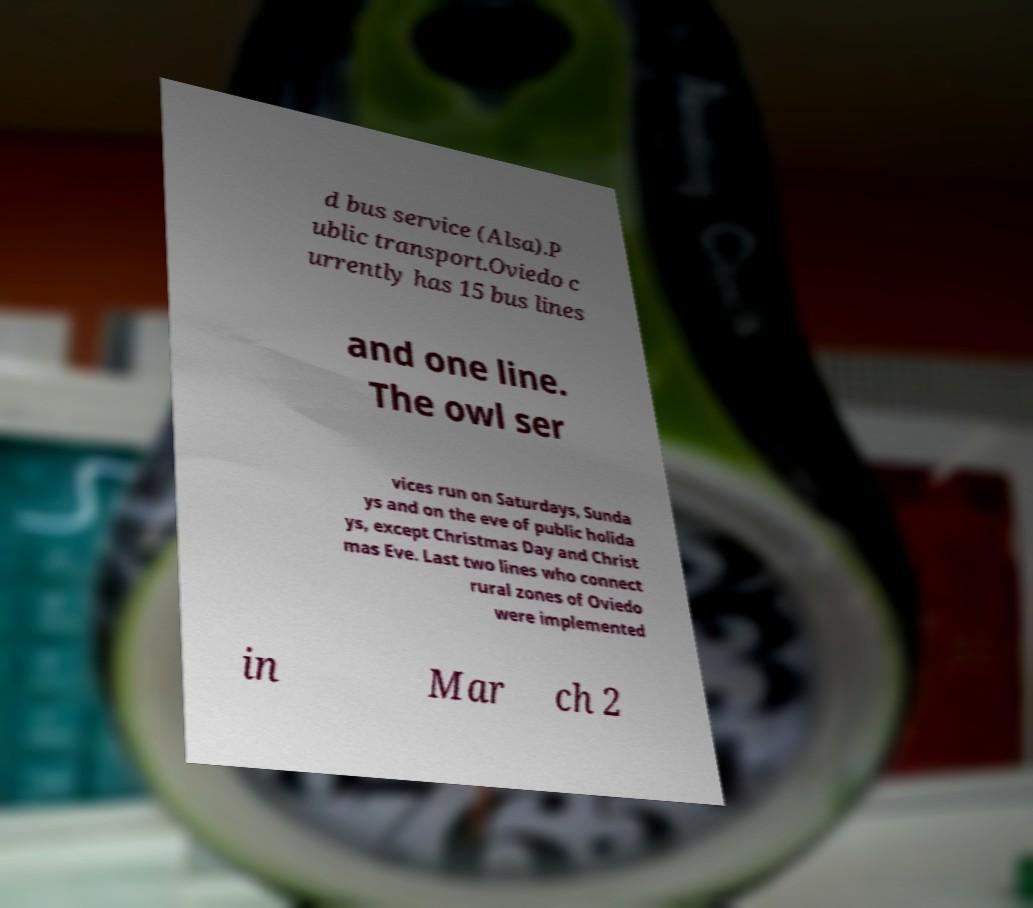For documentation purposes, I need the text within this image transcribed. Could you provide that? d bus service (Alsa).P ublic transport.Oviedo c urrently has 15 bus lines and one line. The owl ser vices run on Saturdays, Sunda ys and on the eve of public holida ys, except Christmas Day and Christ mas Eve. Last two lines who connect rural zones of Oviedo were implemented in Mar ch 2 